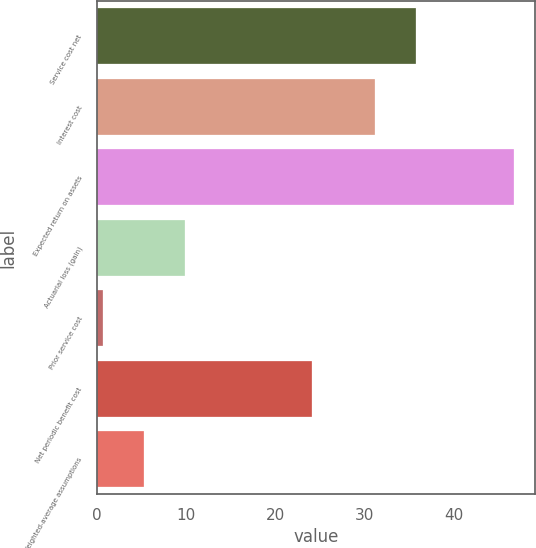<chart> <loc_0><loc_0><loc_500><loc_500><bar_chart><fcel>Service cost net<fcel>Interest cost<fcel>Expected return on assets<fcel>Actuarial loss (gain)<fcel>Prior service cost<fcel>Net periodic benefit cost<fcel>Weighted-average assumptions<nl><fcel>35.81<fcel>31.2<fcel>46.8<fcel>9.92<fcel>0.7<fcel>24.1<fcel>5.31<nl></chart> 